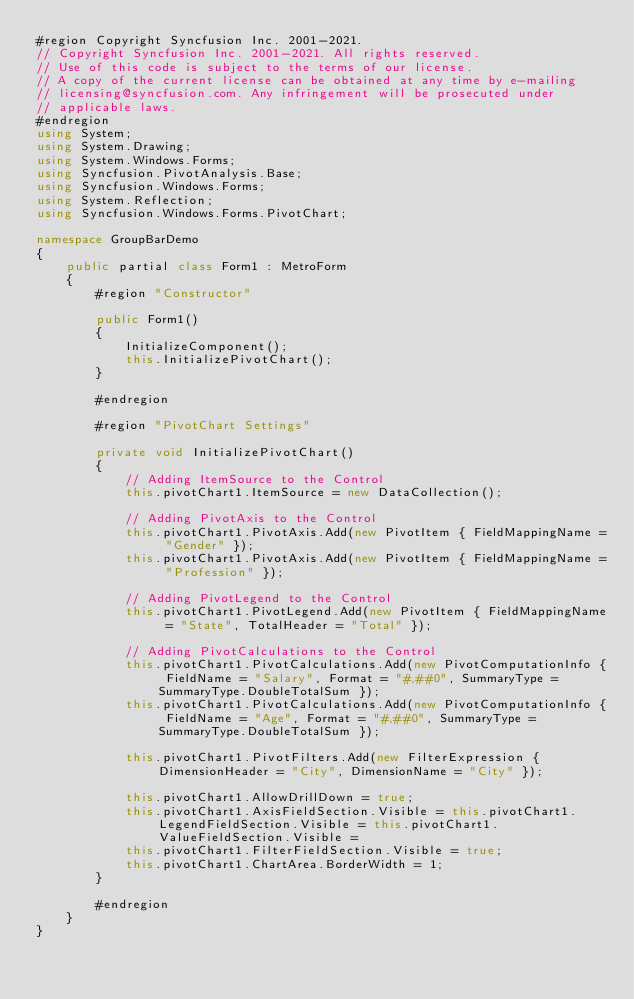Convert code to text. <code><loc_0><loc_0><loc_500><loc_500><_C#_>#region Copyright Syncfusion Inc. 2001-2021.
// Copyright Syncfusion Inc. 2001-2021. All rights reserved.
// Use of this code is subject to the terms of our license.
// A copy of the current license can be obtained at any time by e-mailing
// licensing@syncfusion.com. Any infringement will be prosecuted under
// applicable laws. 
#endregion
using System;
using System.Drawing;
using System.Windows.Forms;
using Syncfusion.PivotAnalysis.Base;
using Syncfusion.Windows.Forms;
using System.Reflection;
using Syncfusion.Windows.Forms.PivotChart;

namespace GroupBarDemo
{
    public partial class Form1 : MetroForm
    {
        #region "Constructor"

        public Form1()
        {
            InitializeComponent();
            this.InitializePivotChart();
        }

        #endregion

        #region "PivotChart Settings"

        private void InitializePivotChart()
        {
            // Adding ItemSource to the Control
            this.pivotChart1.ItemSource = new DataCollection();

            // Adding PivotAxis to the Control
            this.pivotChart1.PivotAxis.Add(new PivotItem { FieldMappingName = "Gender" });
            this.pivotChart1.PivotAxis.Add(new PivotItem { FieldMappingName = "Profession" });

            // Adding PivotLegend to the Control
            this.pivotChart1.PivotLegend.Add(new PivotItem { FieldMappingName = "State", TotalHeader = "Total" });

            // Adding PivotCalculations to the Control
            this.pivotChart1.PivotCalculations.Add(new PivotComputationInfo { FieldName = "Salary", Format = "#,##0", SummaryType = SummaryType.DoubleTotalSum });
            this.pivotChart1.PivotCalculations.Add(new PivotComputationInfo { FieldName = "Age", Format = "#,##0", SummaryType = SummaryType.DoubleTotalSum });

            this.pivotChart1.PivotFilters.Add(new FilterExpression { DimensionHeader = "City", DimensionName = "City" });

            this.pivotChart1.AllowDrillDown = true;
            this.pivotChart1.AxisFieldSection.Visible = this.pivotChart1.LegendFieldSection.Visible = this.pivotChart1.ValueFieldSection.Visible =
            this.pivotChart1.FilterFieldSection.Visible = true;
            this.pivotChart1.ChartArea.BorderWidth = 1;
        }

        #endregion
    }
}</code> 